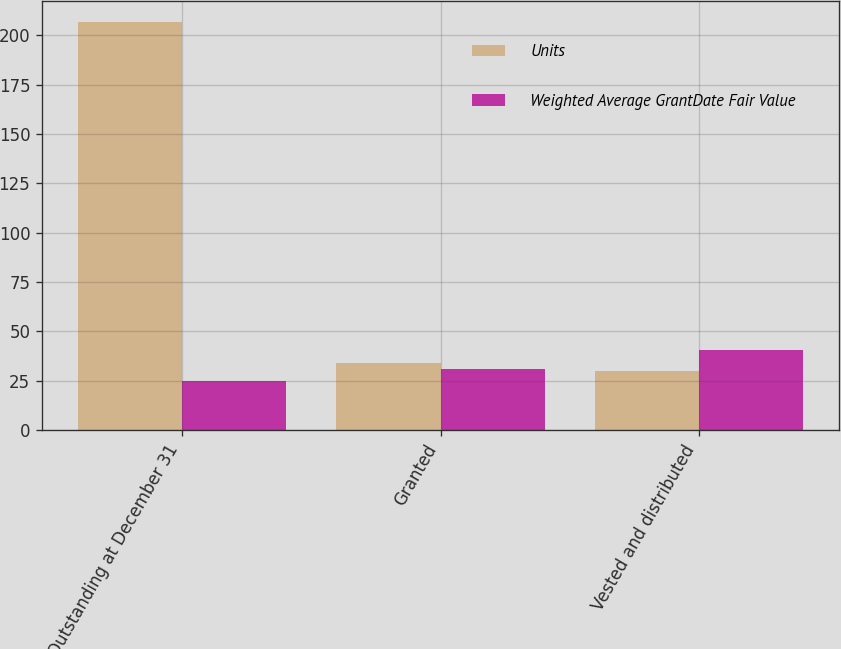<chart> <loc_0><loc_0><loc_500><loc_500><stacked_bar_chart><ecel><fcel>Outstanding at December 31<fcel>Granted<fcel>Vested and distributed<nl><fcel>Units<fcel>207<fcel>34<fcel>30<nl><fcel>Weighted Average GrantDate Fair Value<fcel>24.86<fcel>31.15<fcel>40.63<nl></chart> 